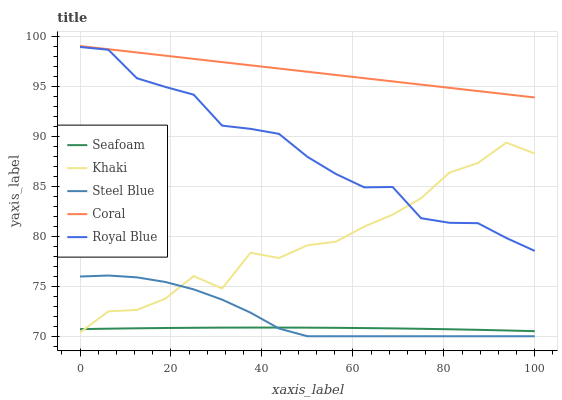Does Seafoam have the minimum area under the curve?
Answer yes or no. Yes. Does Coral have the maximum area under the curve?
Answer yes or no. Yes. Does Khaki have the minimum area under the curve?
Answer yes or no. No. Does Khaki have the maximum area under the curve?
Answer yes or no. No. Is Coral the smoothest?
Answer yes or no. Yes. Is Khaki the roughest?
Answer yes or no. Yes. Is Khaki the smoothest?
Answer yes or no. No. Is Coral the roughest?
Answer yes or no. No. Does Steel Blue have the lowest value?
Answer yes or no. Yes. Does Khaki have the lowest value?
Answer yes or no. No. Does Coral have the highest value?
Answer yes or no. Yes. Does Khaki have the highest value?
Answer yes or no. No. Is Seafoam less than Royal Blue?
Answer yes or no. Yes. Is Royal Blue greater than Steel Blue?
Answer yes or no. Yes. Does Royal Blue intersect Khaki?
Answer yes or no. Yes. Is Royal Blue less than Khaki?
Answer yes or no. No. Is Royal Blue greater than Khaki?
Answer yes or no. No. Does Seafoam intersect Royal Blue?
Answer yes or no. No. 